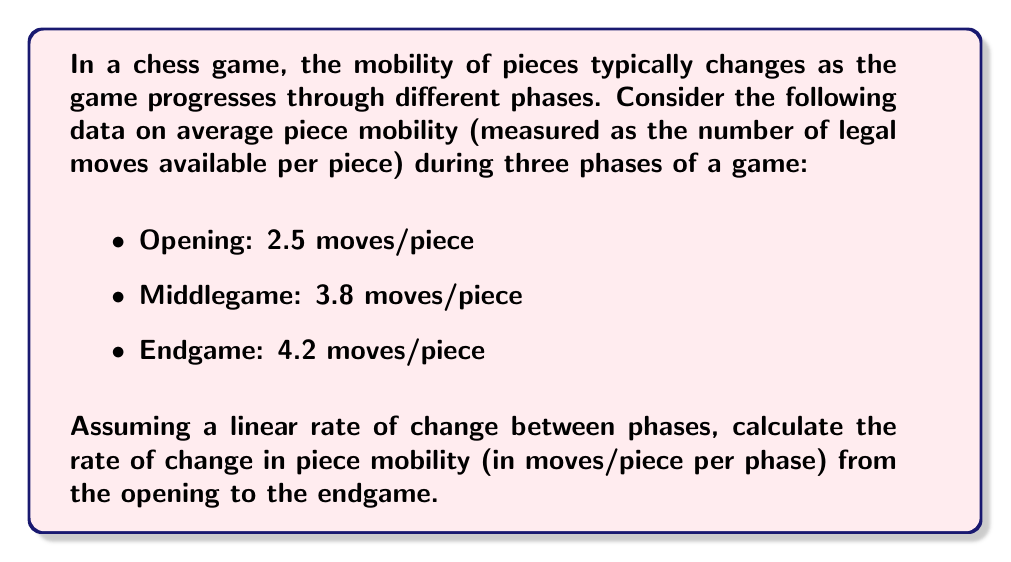Help me with this question. To solve this problem, we need to calculate the rate of change in piece mobility across the phases of the game. We'll use the concept of average rate of change, which is given by the formula:

$$ \text{Rate of Change} = \frac{\text{Change in y}}{\text{Change in x}} $$

In our case:
y = piece mobility (moves/piece)
x = game phase (we'll number them 1 for opening, 2 for middlegame, 3 for endgame)

We'll calculate the total change from opening to endgame:

1. Change in piece mobility:
   $\Delta y = 4.2 - 2.5 = 1.7$ moves/piece

2. Change in game phase:
   $\Delta x = 3 - 1 = 2$ phases

3. Calculating the rate of change:

   $$ \text{Rate of Change} = \frac{1.7 \text{ moves/piece}}{2 \text{ phases}} = 0.85 \text{ moves/piece per phase} $$

This rate represents the average increase in piece mobility per phase from the opening to the endgame, assuming a linear change.
Answer: The rate of change in piece mobility from the opening to the endgame is $0.85$ moves/piece per phase. 